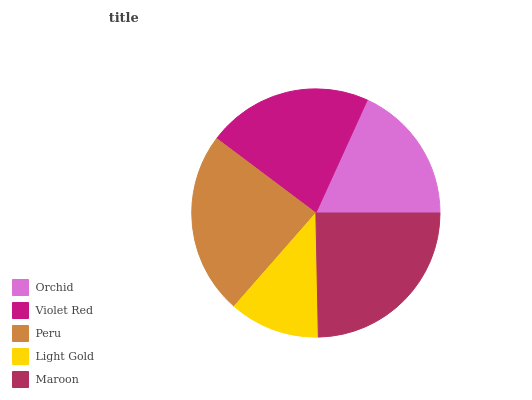Is Light Gold the minimum?
Answer yes or no. Yes. Is Maroon the maximum?
Answer yes or no. Yes. Is Violet Red the minimum?
Answer yes or no. No. Is Violet Red the maximum?
Answer yes or no. No. Is Violet Red greater than Orchid?
Answer yes or no. Yes. Is Orchid less than Violet Red?
Answer yes or no. Yes. Is Orchid greater than Violet Red?
Answer yes or no. No. Is Violet Red less than Orchid?
Answer yes or no. No. Is Violet Red the high median?
Answer yes or no. Yes. Is Violet Red the low median?
Answer yes or no. Yes. Is Orchid the high median?
Answer yes or no. No. Is Maroon the low median?
Answer yes or no. No. 